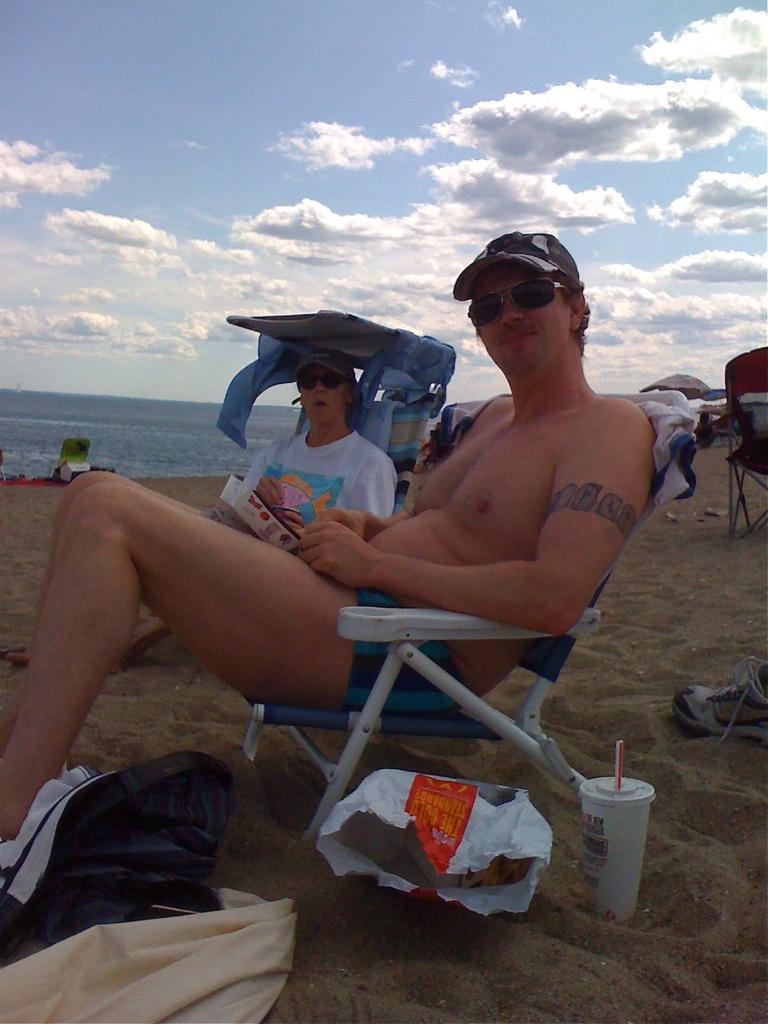Can you describe this image briefly? In this picture, we see two men are sitting on the chairs. At the bottom, we see the sand and the clothes in white and blue color. Beside that, we see the plastic cover and a white glass. On the right side, we see a chair and a shoe. In the background, we see an object in white and green color. Behind that, we see water and this water might be in the sea. At the top, we see the sky and the clouds. 